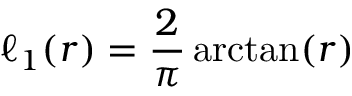Convert formula to latex. <formula><loc_0><loc_0><loc_500><loc_500>\ell _ { 1 } ( r ) = { \frac { 2 } { \pi } } \arctan ( r )</formula> 